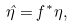Convert formula to latex. <formula><loc_0><loc_0><loc_500><loc_500>\hat { \eta } = f ^ { * } \eta ,</formula> 